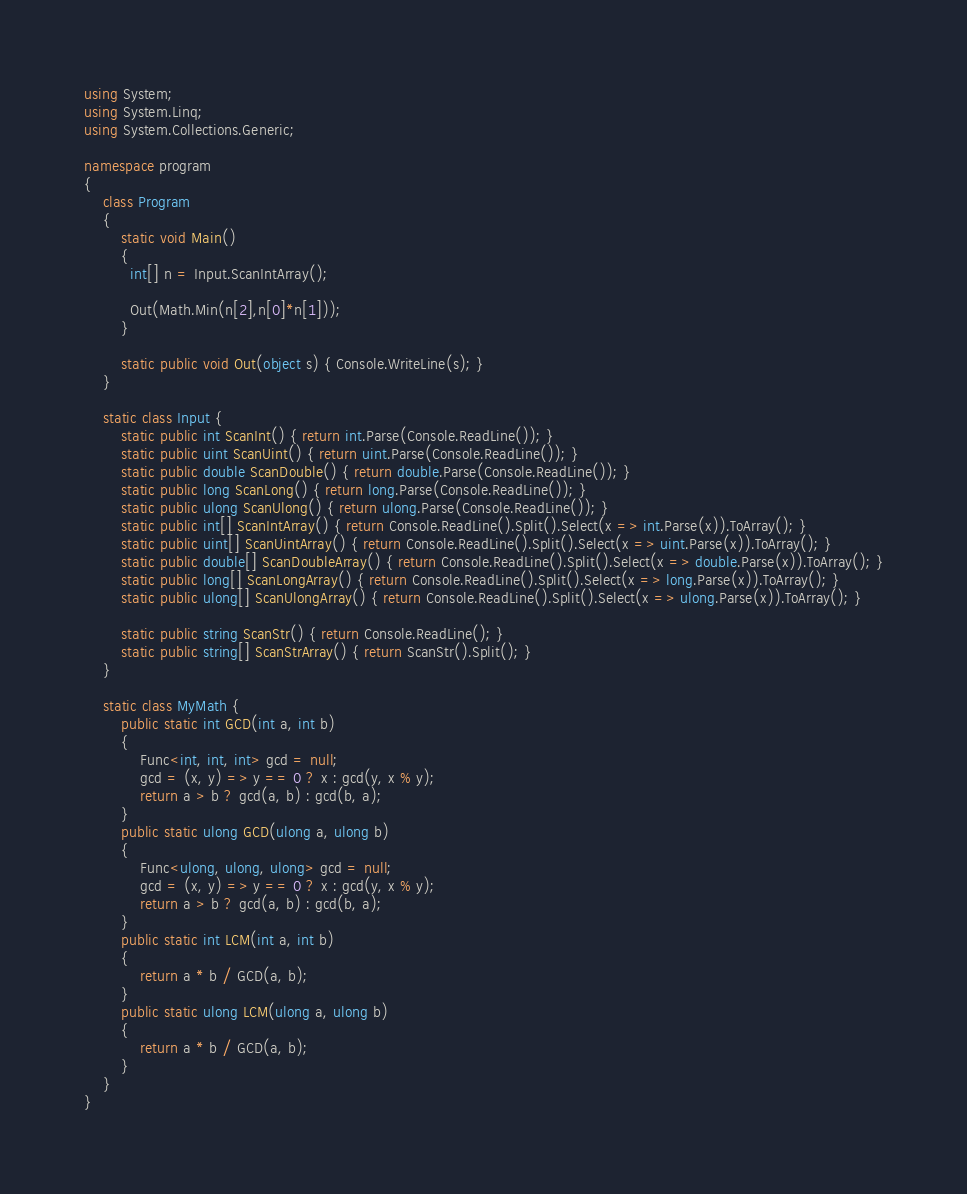Convert code to text. <code><loc_0><loc_0><loc_500><loc_500><_C#_>using System;
using System.Linq;
using System.Collections.Generic;

namespace program
{
    class Program
    {
        static void Main()
        {
          int[] n = Input.ScanIntArray();
          
          Out(Math.Min(n[2],n[0]*n[1]));
        }

        static public void Out(object s) { Console.WriteLine(s); }
    }
    
    static class Input {
        static public int ScanInt() { return int.Parse(Console.ReadLine()); }
        static public uint ScanUint() { return uint.Parse(Console.ReadLine()); }
        static public double ScanDouble() { return double.Parse(Console.ReadLine()); }
        static public long ScanLong() { return long.Parse(Console.ReadLine()); }
        static public ulong ScanUlong() { return ulong.Parse(Console.ReadLine()); }
        static public int[] ScanIntArray() { return Console.ReadLine().Split().Select(x => int.Parse(x)).ToArray(); }
        static public uint[] ScanUintArray() { return Console.ReadLine().Split().Select(x => uint.Parse(x)).ToArray(); }
        static public double[] ScanDoubleArray() { return Console.ReadLine().Split().Select(x => double.Parse(x)).ToArray(); }
        static public long[] ScanLongArray() { return Console.ReadLine().Split().Select(x => long.Parse(x)).ToArray(); }
        static public ulong[] ScanUlongArray() { return Console.ReadLine().Split().Select(x => ulong.Parse(x)).ToArray(); }

        static public string ScanStr() { return Console.ReadLine(); }
        static public string[] ScanStrArray() { return ScanStr().Split(); }
    }

    static class MyMath {
        public static int GCD(int a, int b)
        {
            Func<int, int, int> gcd = null;
            gcd = (x, y) => y == 0 ? x : gcd(y, x % y);
            return a > b ? gcd(a, b) : gcd(b, a);
        }
        public static ulong GCD(ulong a, ulong b)
        {
            Func<ulong, ulong, ulong> gcd = null;
            gcd = (x, y) => y == 0 ? x : gcd(y, x % y);
            return a > b ? gcd(a, b) : gcd(b, a);
        }
        public static int LCM(int a, int b)
        {
            return a * b / GCD(a, b);
        }
        public static ulong LCM(ulong a, ulong b)
        {
            return a * b / GCD(a, b);
        }
    }
}
</code> 